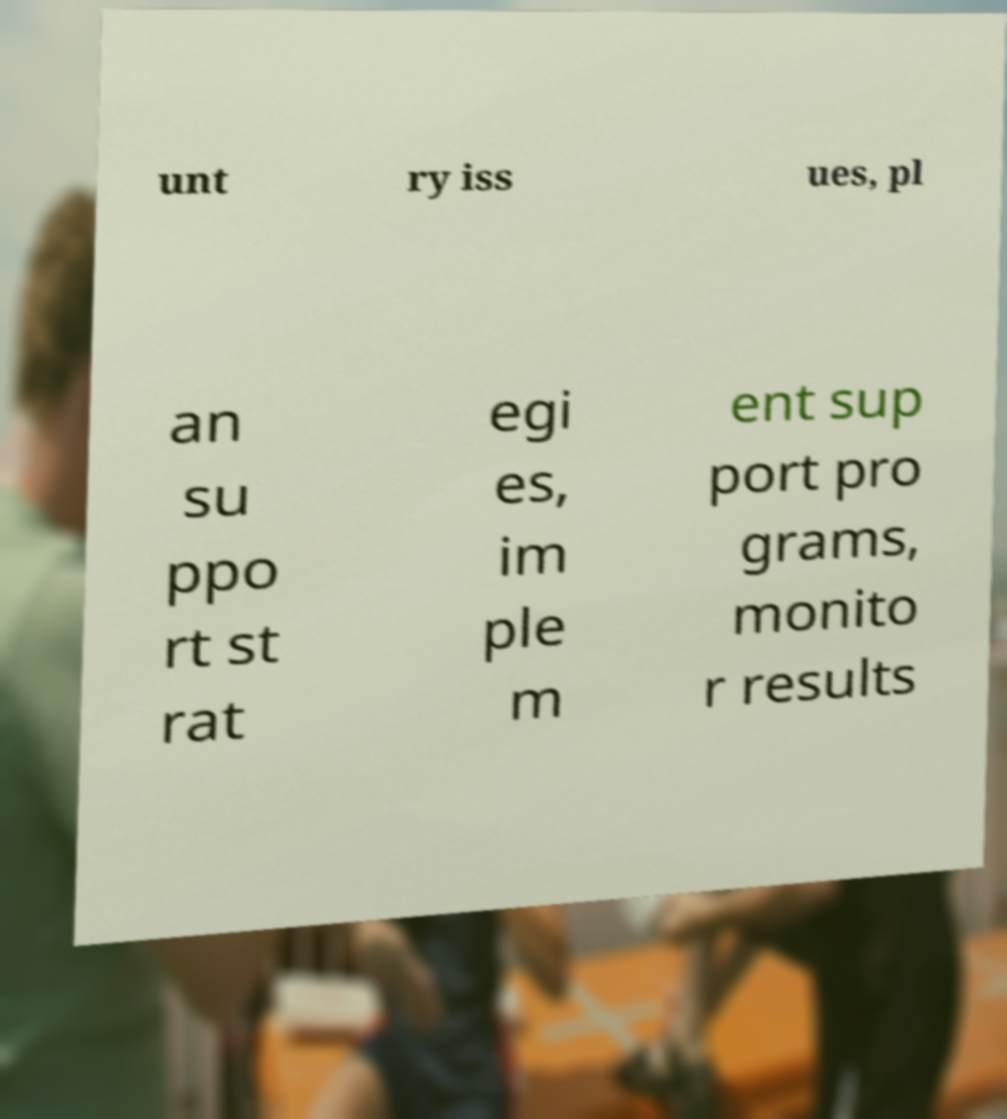What messages or text are displayed in this image? I need them in a readable, typed format. unt ry iss ues, pl an su ppo rt st rat egi es, im ple m ent sup port pro grams, monito r results 